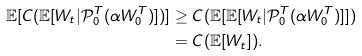Convert formula to latex. <formula><loc_0><loc_0><loc_500><loc_500>\mathbb { E } [ C ( \mathbb { E } [ W _ { t } | \mathcal { P } _ { 0 } ^ { T } ( \alpha W _ { 0 } ^ { T } ) ] ) ] & \geq C ( \mathbb { E } [ \mathbb { E } [ W _ { t } | \mathcal { P } _ { 0 } ^ { T } ( \alpha W _ { 0 } ^ { T } ) ] ] ) \\ & = C ( \mathbb { E } [ W _ { t } ] ) .</formula> 